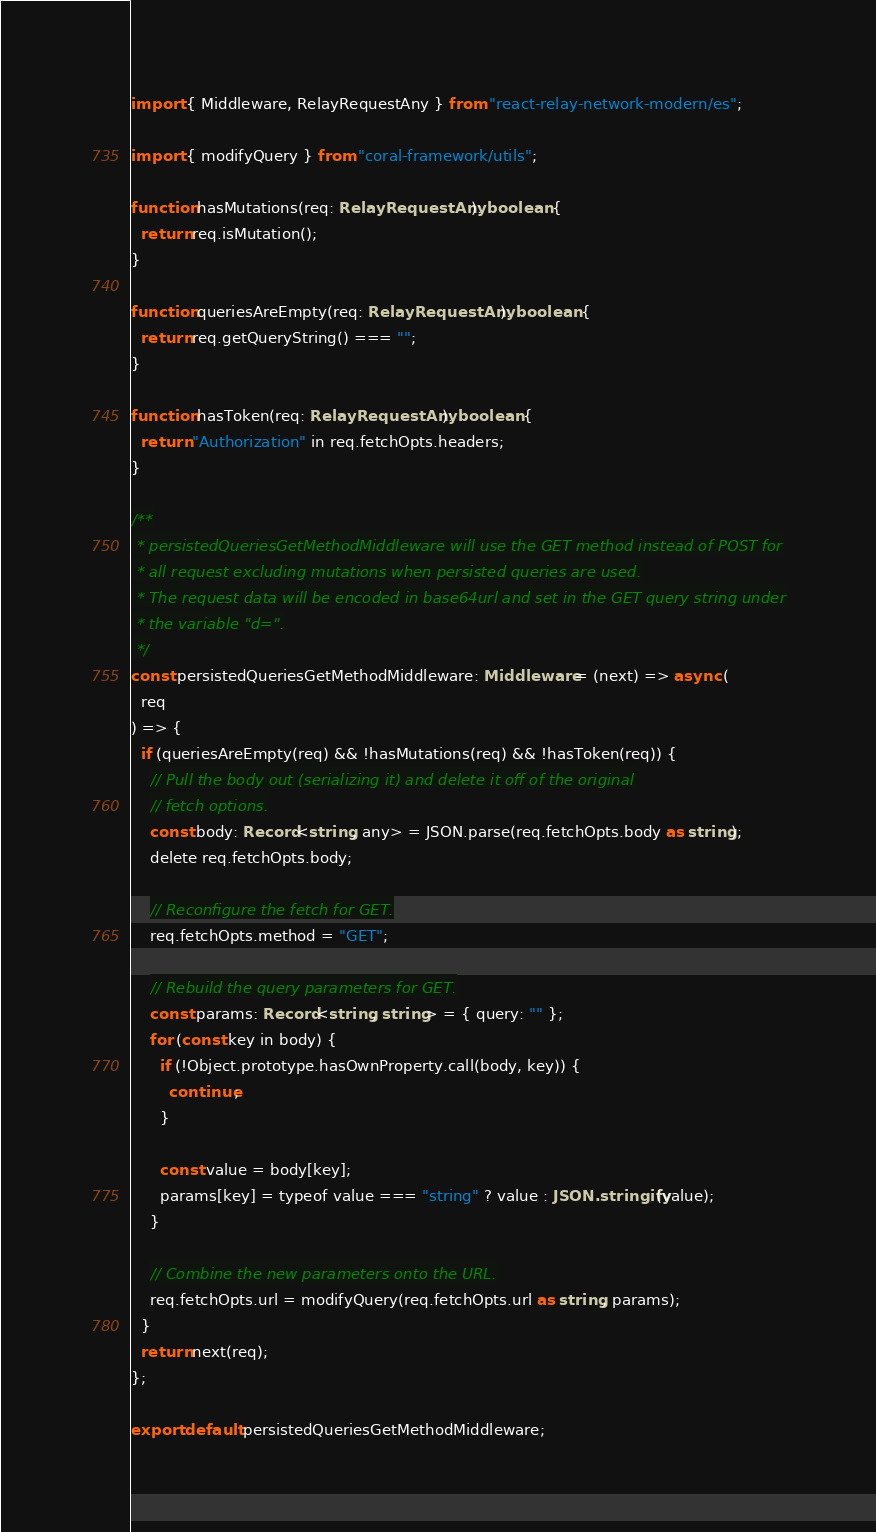Convert code to text. <code><loc_0><loc_0><loc_500><loc_500><_TypeScript_>import { Middleware, RelayRequestAny } from "react-relay-network-modern/es";

import { modifyQuery } from "coral-framework/utils";

function hasMutations(req: RelayRequestAny): boolean {
  return req.isMutation();
}

function queriesAreEmpty(req: RelayRequestAny): boolean {
  return req.getQueryString() === "";
}

function hasToken(req: RelayRequestAny): boolean {
  return "Authorization" in req.fetchOpts.headers;
}

/**
 * persistedQueriesGetMethodMiddleware will use the GET method instead of POST for
 * all request excluding mutations when persisted queries are used.
 * The request data will be encoded in base64url and set in the GET query string under
 * the variable "d=".
 */
const persistedQueriesGetMethodMiddleware: Middleware = (next) => async (
  req
) => {
  if (queriesAreEmpty(req) && !hasMutations(req) && !hasToken(req)) {
    // Pull the body out (serializing it) and delete it off of the original
    // fetch options.
    const body: Record<string, any> = JSON.parse(req.fetchOpts.body as string);
    delete req.fetchOpts.body;

    // Reconfigure the fetch for GET.
    req.fetchOpts.method = "GET";

    // Rebuild the query parameters for GET.
    const params: Record<string, string> = { query: "" };
    for (const key in body) {
      if (!Object.prototype.hasOwnProperty.call(body, key)) {
        continue;
      }

      const value = body[key];
      params[key] = typeof value === "string" ? value : JSON.stringify(value);
    }

    // Combine the new parameters onto the URL.
    req.fetchOpts.url = modifyQuery(req.fetchOpts.url as string, params);
  }
  return next(req);
};

export default persistedQueriesGetMethodMiddleware;
</code> 